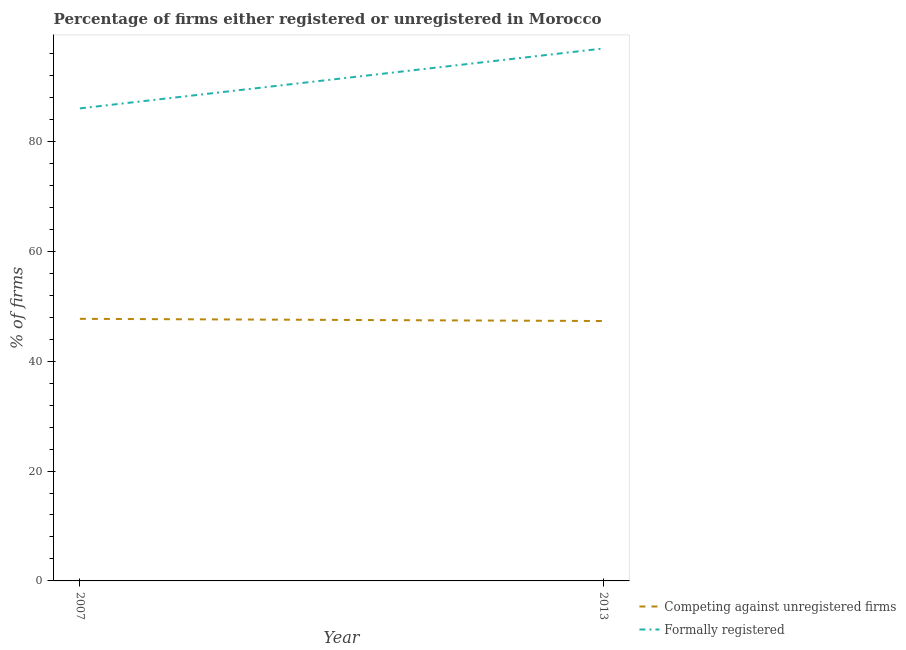How many different coloured lines are there?
Provide a succinct answer. 2. Is the number of lines equal to the number of legend labels?
Make the answer very short. Yes. What is the percentage of registered firms in 2013?
Make the answer very short. 47.3. Across all years, what is the maximum percentage of formally registered firms?
Your answer should be very brief. 96.9. What is the total percentage of registered firms in the graph?
Provide a short and direct response. 95. What is the difference between the percentage of formally registered firms in 2007 and that in 2013?
Give a very brief answer. -10.9. What is the difference between the percentage of registered firms in 2013 and the percentage of formally registered firms in 2007?
Offer a terse response. -38.7. What is the average percentage of formally registered firms per year?
Your answer should be very brief. 91.45. In the year 2007, what is the difference between the percentage of formally registered firms and percentage of registered firms?
Offer a very short reply. 38.3. What is the ratio of the percentage of registered firms in 2007 to that in 2013?
Offer a very short reply. 1.01. Is the percentage of formally registered firms in 2007 less than that in 2013?
Make the answer very short. Yes. Is the percentage of formally registered firms strictly greater than the percentage of registered firms over the years?
Your response must be concise. Yes. How many lines are there?
Keep it short and to the point. 2. How many years are there in the graph?
Ensure brevity in your answer.  2. Does the graph contain any zero values?
Make the answer very short. No. Does the graph contain grids?
Make the answer very short. No. How many legend labels are there?
Your answer should be very brief. 2. How are the legend labels stacked?
Give a very brief answer. Vertical. What is the title of the graph?
Ensure brevity in your answer.  Percentage of firms either registered or unregistered in Morocco. Does "Boys" appear as one of the legend labels in the graph?
Your answer should be compact. No. What is the label or title of the Y-axis?
Your response must be concise. % of firms. What is the % of firms of Competing against unregistered firms in 2007?
Your answer should be very brief. 47.7. What is the % of firms of Formally registered in 2007?
Offer a terse response. 86. What is the % of firms in Competing against unregistered firms in 2013?
Your response must be concise. 47.3. What is the % of firms of Formally registered in 2013?
Your answer should be very brief. 96.9. Across all years, what is the maximum % of firms of Competing against unregistered firms?
Provide a short and direct response. 47.7. Across all years, what is the maximum % of firms in Formally registered?
Provide a short and direct response. 96.9. Across all years, what is the minimum % of firms in Competing against unregistered firms?
Your answer should be compact. 47.3. What is the total % of firms of Competing against unregistered firms in the graph?
Offer a terse response. 95. What is the total % of firms in Formally registered in the graph?
Keep it short and to the point. 182.9. What is the difference between the % of firms of Competing against unregistered firms in 2007 and that in 2013?
Give a very brief answer. 0.4. What is the difference between the % of firms in Formally registered in 2007 and that in 2013?
Your response must be concise. -10.9. What is the difference between the % of firms in Competing against unregistered firms in 2007 and the % of firms in Formally registered in 2013?
Provide a short and direct response. -49.2. What is the average % of firms of Competing against unregistered firms per year?
Your answer should be very brief. 47.5. What is the average % of firms of Formally registered per year?
Give a very brief answer. 91.45. In the year 2007, what is the difference between the % of firms of Competing against unregistered firms and % of firms of Formally registered?
Your response must be concise. -38.3. In the year 2013, what is the difference between the % of firms in Competing against unregistered firms and % of firms in Formally registered?
Make the answer very short. -49.6. What is the ratio of the % of firms in Competing against unregistered firms in 2007 to that in 2013?
Keep it short and to the point. 1.01. What is the ratio of the % of firms of Formally registered in 2007 to that in 2013?
Your answer should be very brief. 0.89. What is the difference between the highest and the second highest % of firms in Competing against unregistered firms?
Offer a very short reply. 0.4. What is the difference between the highest and the second highest % of firms of Formally registered?
Offer a very short reply. 10.9. What is the difference between the highest and the lowest % of firms of Formally registered?
Give a very brief answer. 10.9. 